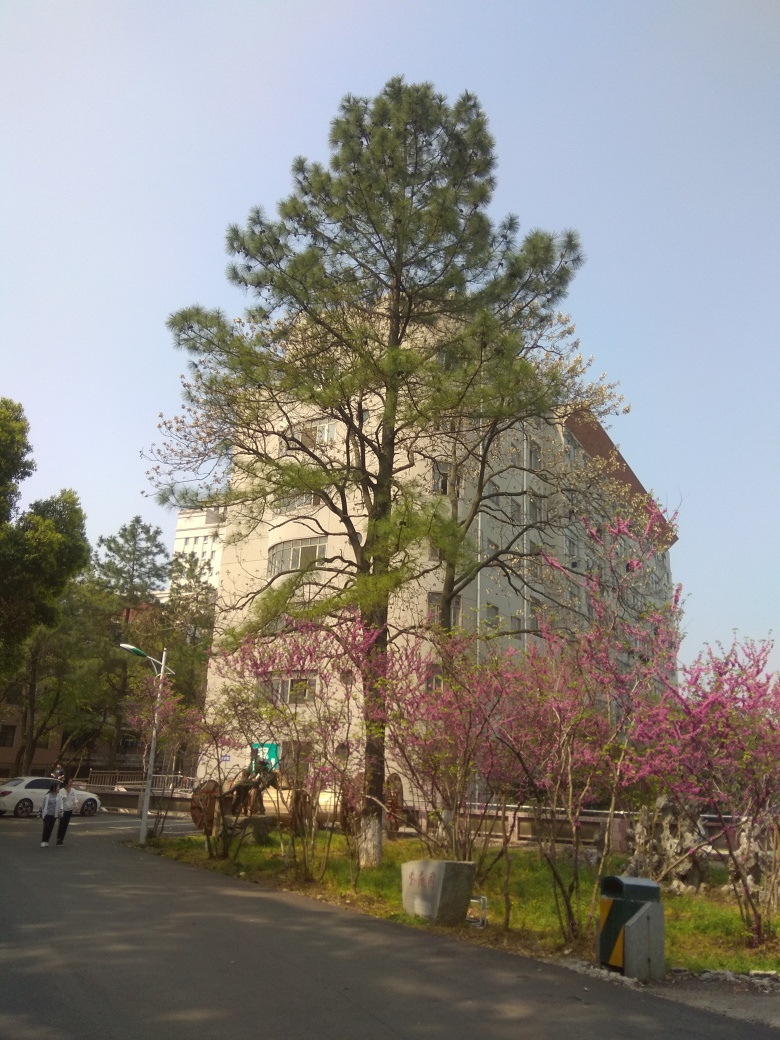Can you tell me more about the flora in this image? Certainly! The image prominently features a tall coniferous tree, which appears to be a type of pine, characterized by its needle-like leaves and conical shape. In the foreground, there are flowering shrubs with pink blossoms, likely redbud or cherry, which are common in temperate regions and are known for their vibrant flowers that bloom in spring. 